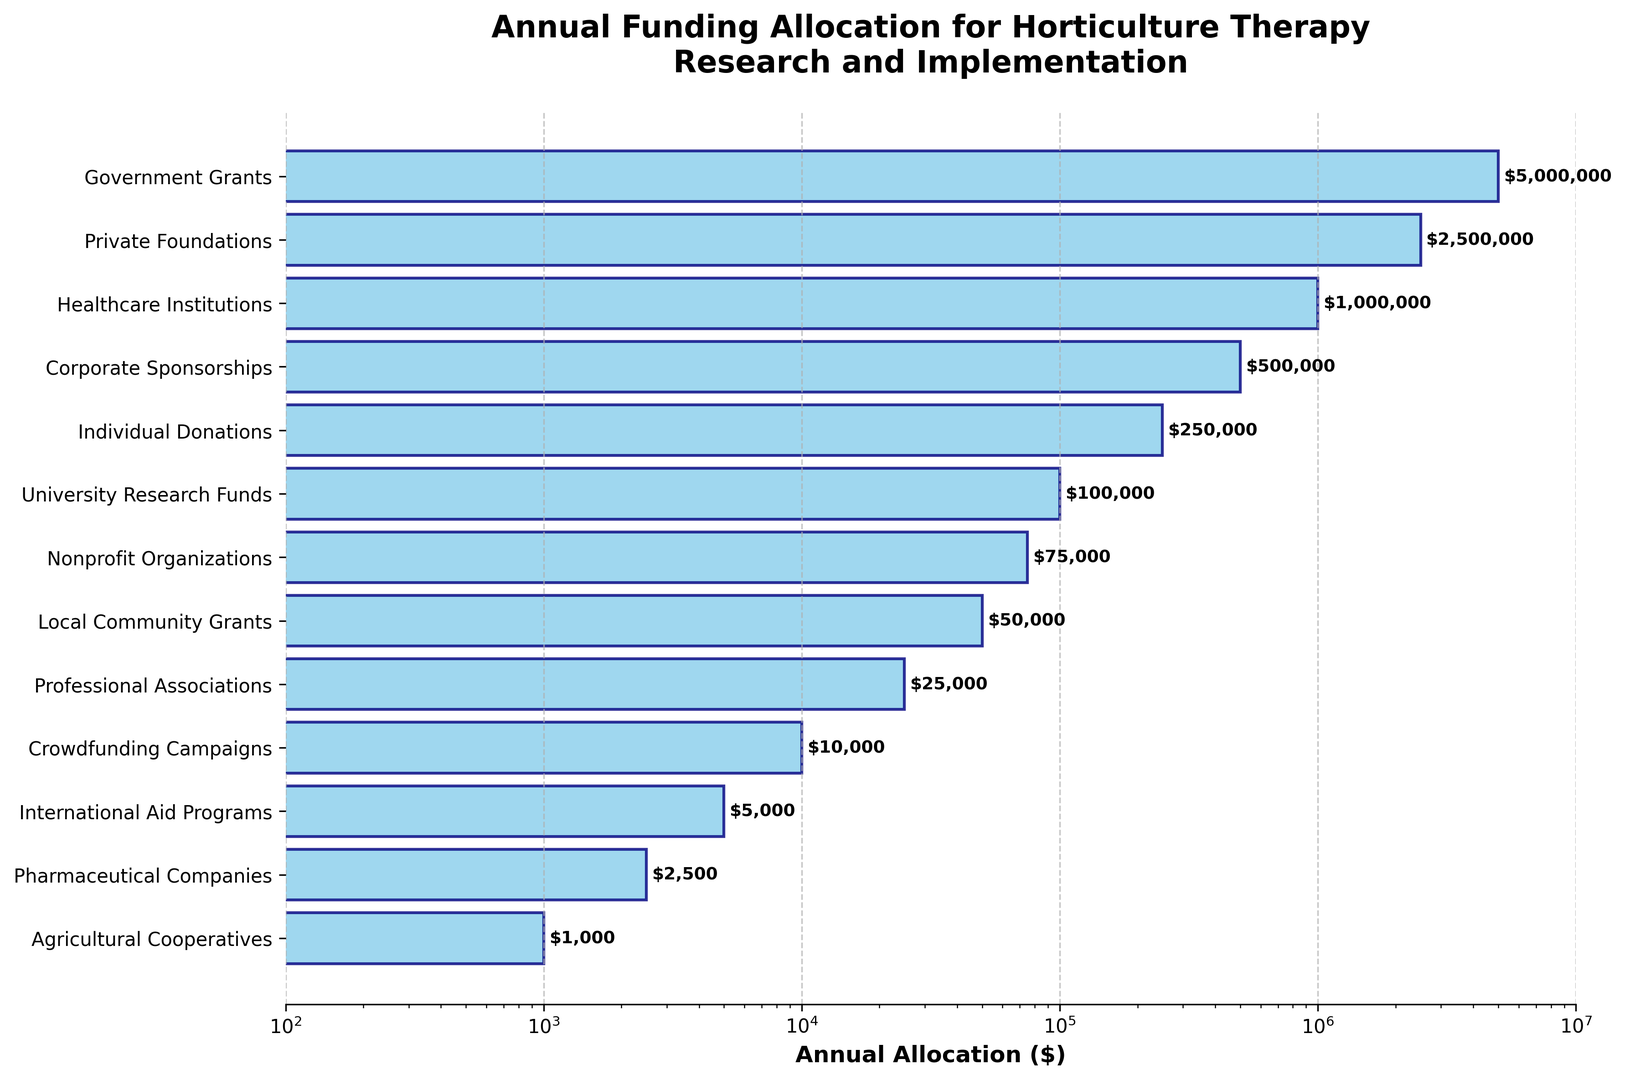What is the largest funding source for horticulture therapy? The chart shows several funding sources and their allocations. The largest bar represents "Government Grants," which is the longest and closest to the right side on the logarithmic scale.
Answer: Government Grants Which funding source has the smallest allocation? The smallest bar on the chart is for "Agricultural Cooperatives," indicating the least funding. It is the shortest bar closest to the right side of the x-axis.
Answer: Agricultural Cooperatives How does the funding from Private Foundations compare to University Research Funds? On the chart, the bar for "Private Foundations" is much longer than the bar for "University Research Funds," indicating that Private Foundations contribute significantly more.
Answer: Private Foundations provides more funding What is the total funding from Government Grants and Private Foundations combined? "Government Grants" have an allocation of $5,000,000, and "Private Foundations" have $2,500,000. Adding these together: $5,000,000 + $2,500,000 = $7,500,000.
Answer: $7,500,000 Are Corporate Sponsorships funding more or less than Individual Donations? The chart shows that "Corporate Sponsorships" have a longer bar compared to "Individual Donations," indicating higher funding.
Answer: Corporate Sponsorships provide more funding Which sources have funding allocations between $1,000 and $100,000 based on the log scale? The bars between $1,000 and $100,000 are for "Nonprofit Organizations," "Local Community Grants," "Professional Associations," and "Crowdfunding Campaigns." These bars fall within the indicated log scale range.
Answer: Nonprofit Organizations, Local Community Grants, Professional Associations, Crowdfunding Campaigns What is the proportion of funding from Healthcare Institutions relative to the total funding from all sources? The total allocation is the sum of all individual allocations. For Healthcare Institutions: ($5,000,000 + $2,500,000 + $1,000,000 + $500,000 + $250,000 + $100,000 + $75,000 + $50,000 + $25,000 + $10,000 + $5,000 + $2,500 + $1,000) = $9,518,500. The proportion for Healthcare Institutions is $1,000,000 / $9,518,500 ≈ 0.105 or 10.5%.
Answer: 10.5% How does the log scale help in visualizing the funding sources? The log scale compresses the wide range of funding amounts into a more readable format, highlighting even smaller contributions. Without it, visual differences between small and large amounts might be harder to see.
Answer: It compresses the range, enhancing readability 